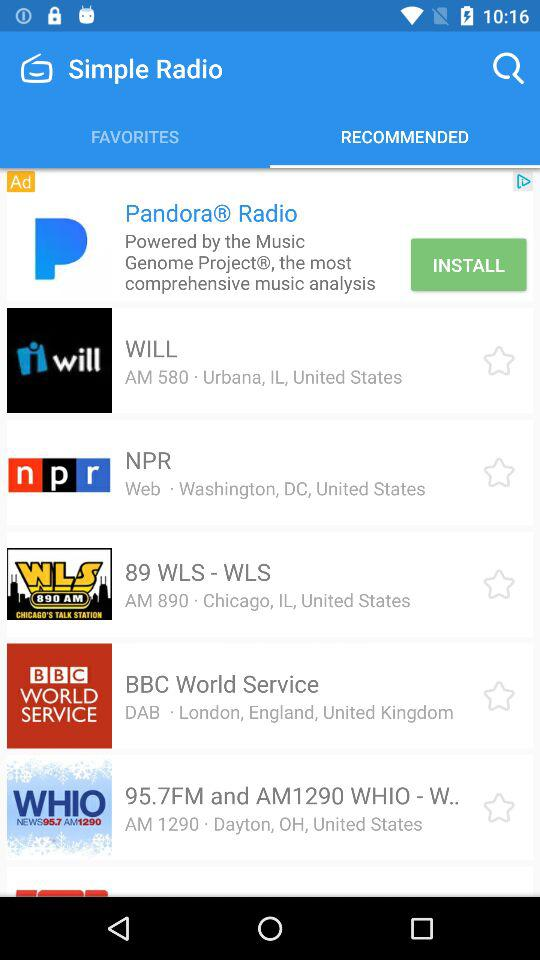Where is NPR located? The NPR is located at Washington, DC, United States. 